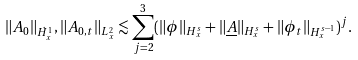<formula> <loc_0><loc_0><loc_500><loc_500>\| A _ { 0 } \| _ { \dot { H } ^ { 1 } _ { x } } , \| A _ { 0 , t } \| _ { L ^ { 2 } _ { x } } \lesssim \sum _ { j = 2 } ^ { 3 } ( \| \phi \| _ { H ^ { s } _ { x } } + \| \underline { A } \| _ { H ^ { s } _ { x } } + \| \phi _ { t } \| _ { H ^ { s - 1 } _ { x } } ) ^ { j } .</formula> 